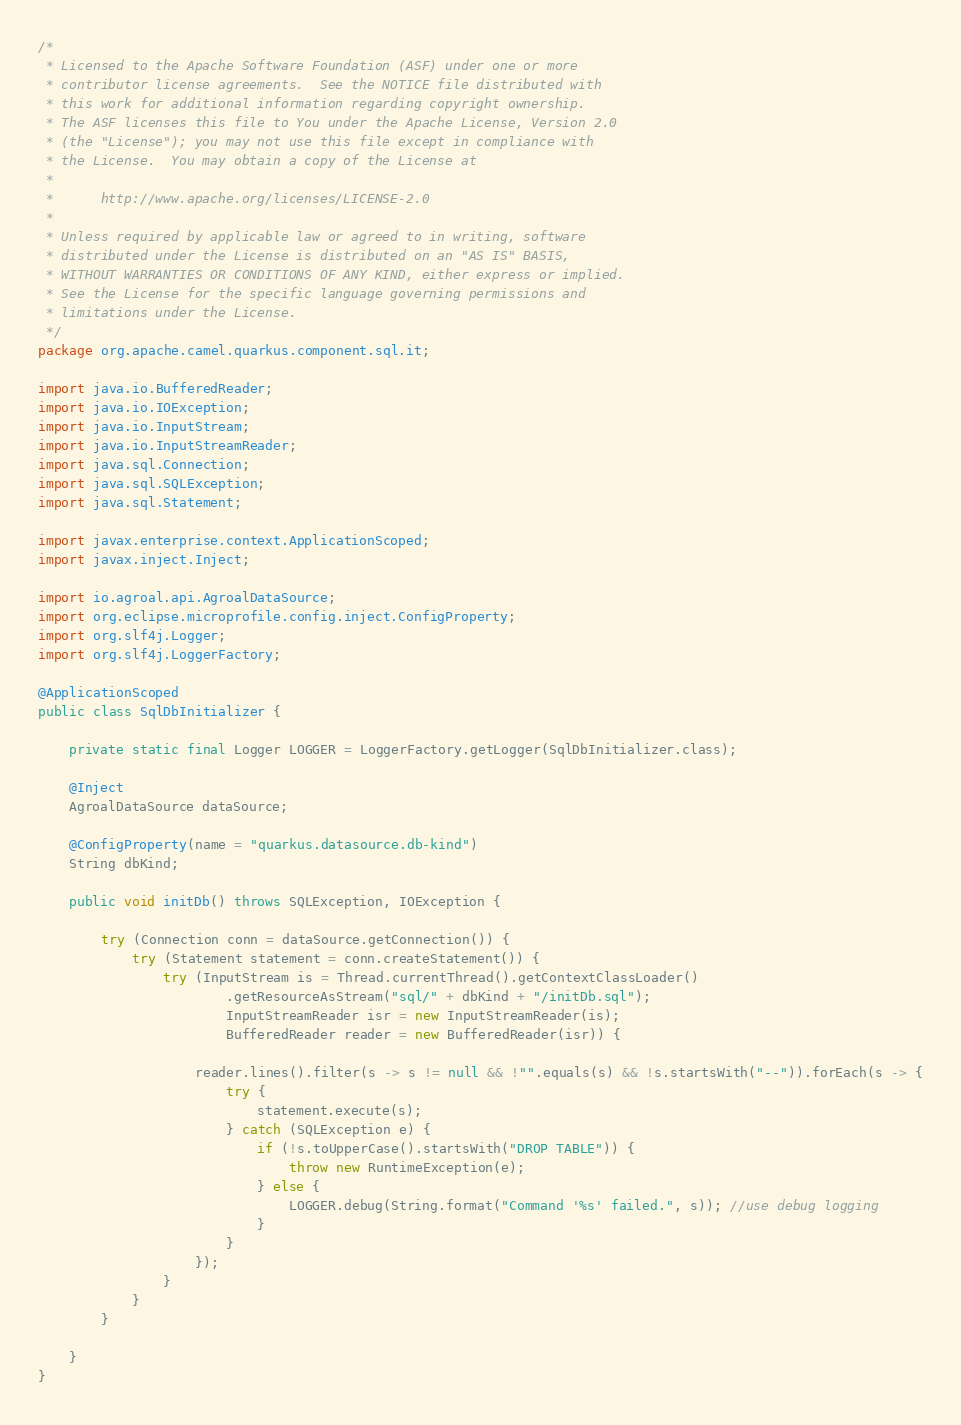Convert code to text. <code><loc_0><loc_0><loc_500><loc_500><_Java_>/*
 * Licensed to the Apache Software Foundation (ASF) under one or more
 * contributor license agreements.  See the NOTICE file distributed with
 * this work for additional information regarding copyright ownership.
 * The ASF licenses this file to You under the Apache License, Version 2.0
 * (the "License"); you may not use this file except in compliance with
 * the License.  You may obtain a copy of the License at
 *
 *      http://www.apache.org/licenses/LICENSE-2.0
 *
 * Unless required by applicable law or agreed to in writing, software
 * distributed under the License is distributed on an "AS IS" BASIS,
 * WITHOUT WARRANTIES OR CONDITIONS OF ANY KIND, either express or implied.
 * See the License for the specific language governing permissions and
 * limitations under the License.
 */
package org.apache.camel.quarkus.component.sql.it;

import java.io.BufferedReader;
import java.io.IOException;
import java.io.InputStream;
import java.io.InputStreamReader;
import java.sql.Connection;
import java.sql.SQLException;
import java.sql.Statement;

import javax.enterprise.context.ApplicationScoped;
import javax.inject.Inject;

import io.agroal.api.AgroalDataSource;
import org.eclipse.microprofile.config.inject.ConfigProperty;
import org.slf4j.Logger;
import org.slf4j.LoggerFactory;

@ApplicationScoped
public class SqlDbInitializer {

    private static final Logger LOGGER = LoggerFactory.getLogger(SqlDbInitializer.class);

    @Inject
    AgroalDataSource dataSource;

    @ConfigProperty(name = "quarkus.datasource.db-kind")
    String dbKind;

    public void initDb() throws SQLException, IOException {

        try (Connection conn = dataSource.getConnection()) {
            try (Statement statement = conn.createStatement()) {
                try (InputStream is = Thread.currentThread().getContextClassLoader()
                        .getResourceAsStream("sql/" + dbKind + "/initDb.sql");
                        InputStreamReader isr = new InputStreamReader(is);
                        BufferedReader reader = new BufferedReader(isr)) {

                    reader.lines().filter(s -> s != null && !"".equals(s) && !s.startsWith("--")).forEach(s -> {
                        try {
                            statement.execute(s);
                        } catch (SQLException e) {
                            if (!s.toUpperCase().startsWith("DROP TABLE")) {
                                throw new RuntimeException(e);
                            } else {
                                LOGGER.debug(String.format("Command '%s' failed.", s)); //use debug logging
                            }
                        }
                    });
                }
            }
        }

    }
}
</code> 